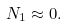<formula> <loc_0><loc_0><loc_500><loc_500>N _ { 1 } \approx 0 .</formula> 